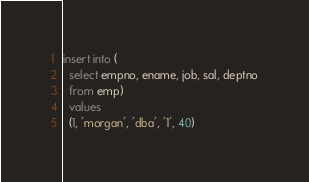Convert code to text. <code><loc_0><loc_0><loc_500><loc_500><_SQL_>insert into (
  select empno, ename, job, sal, deptno
  from emp)
  values
  (1, 'morgan', 'dba', '1', 40)
</code> 